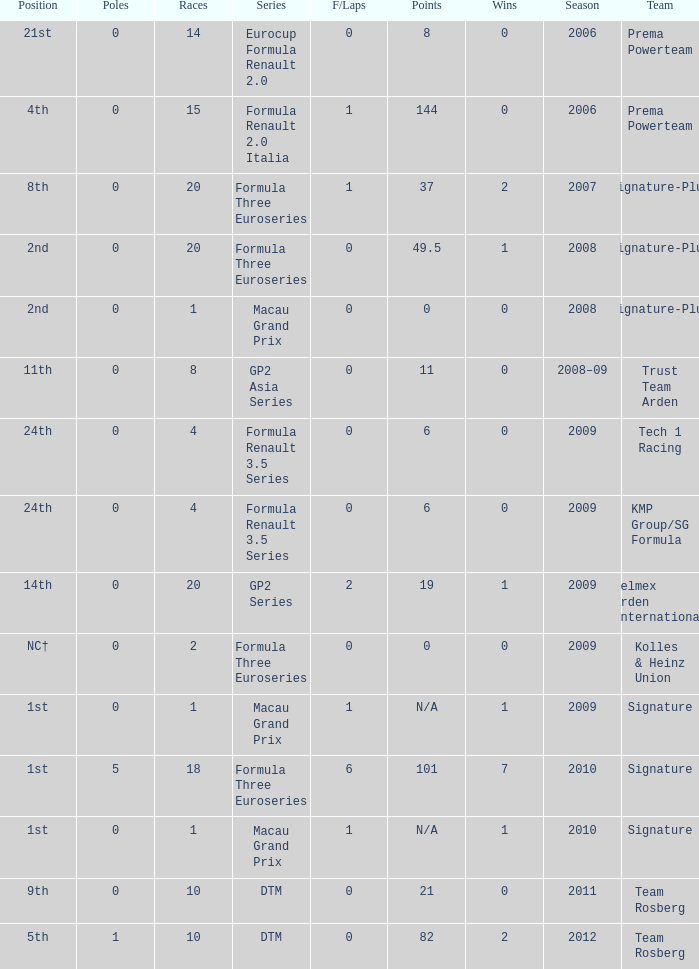Parse the full table. {'header': ['Position', 'Poles', 'Races', 'Series', 'F/Laps', 'Points', 'Wins', 'Season', 'Team'], 'rows': [['21st', '0', '14', 'Eurocup Formula Renault 2.0', '0', '8', '0', '2006', 'Prema Powerteam'], ['4th', '0', '15', 'Formula Renault 2.0 Italia', '1', '144', '0', '2006', 'Prema Powerteam'], ['8th', '0', '20', 'Formula Three Euroseries', '1', '37', '2', '2007', 'Signature-Plus'], ['2nd', '0', '20', 'Formula Three Euroseries', '0', '49.5', '1', '2008', 'Signature-Plus'], ['2nd', '0', '1', 'Macau Grand Prix', '0', '0', '0', '2008', 'Signature-Plus'], ['11th', '0', '8', 'GP2 Asia Series', '0', '11', '0', '2008–09', 'Trust Team Arden'], ['24th', '0', '4', 'Formula Renault 3.5 Series', '0', '6', '0', '2009', 'Tech 1 Racing'], ['24th', '0', '4', 'Formula Renault 3.5 Series', '0', '6', '0', '2009', 'KMP Group/SG Formula'], ['14th', '0', '20', 'GP2 Series', '2', '19', '1', '2009', 'Telmex Arden International'], ['NC†', '0', '2', 'Formula Three Euroseries', '0', '0', '0', '2009', 'Kolles & Heinz Union'], ['1st', '0', '1', 'Macau Grand Prix', '1', 'N/A', '1', '2009', 'Signature'], ['1st', '5', '18', 'Formula Three Euroseries', '6', '101', '7', '2010', 'Signature'], ['1st', '0', '1', 'Macau Grand Prix', '1', 'N/A', '1', '2010', 'Signature'], ['9th', '0', '10', 'DTM', '0', '21', '0', '2011', 'Team Rosberg'], ['5th', '1', '10', 'DTM', '0', '82', '2', '2012', 'Team Rosberg']]} How many poles are there in the Formula Three Euroseries in the 2008 season with more than 0 F/Laps? None. 